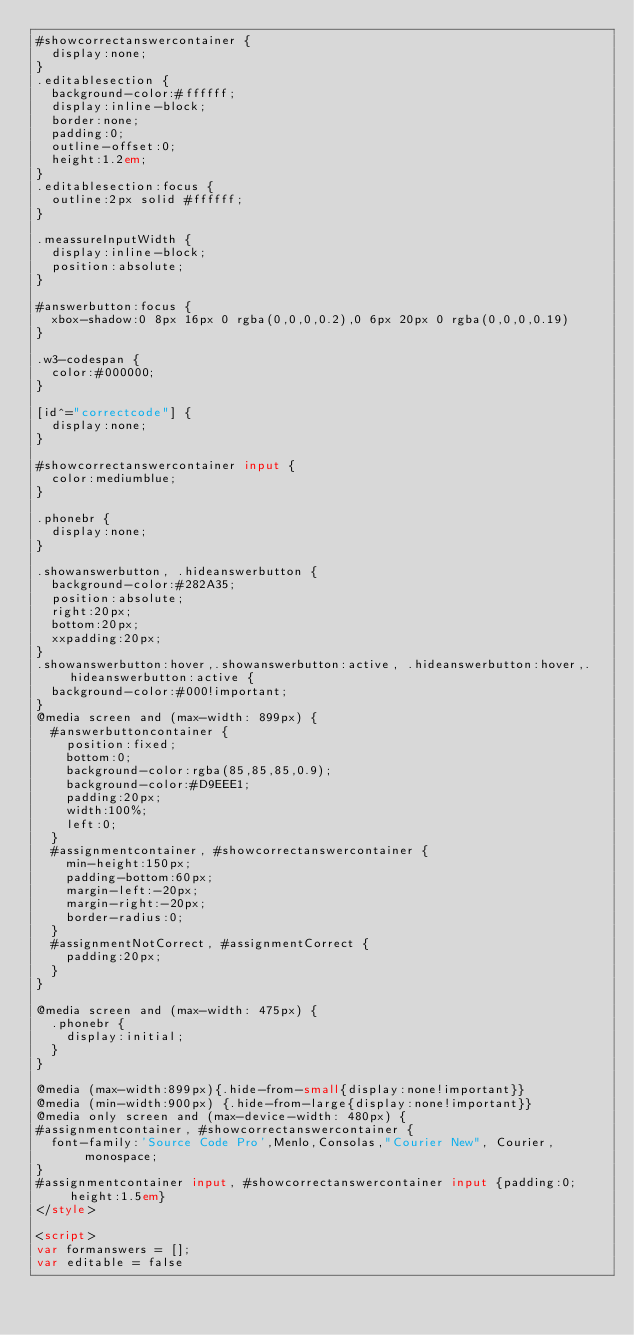<code> <loc_0><loc_0><loc_500><loc_500><_HTML_>#showcorrectanswercontainer {
  display:none;
}
.editablesection {
  background-color:#ffffff;
  display:inline-block;
  border:none;
  padding:0;
  outline-offset:0;
  height:1.2em;
}
.editablesection:focus {
  outline:2px solid #ffffff;
}

.meassureInputWidth {
  display:inline-block;
  position:absolute;
}

#answerbutton:focus {
  xbox-shadow:0 8px 16px 0 rgba(0,0,0,0.2),0 6px 20px 0 rgba(0,0,0,0.19)
}

.w3-codespan {
  color:#000000;
}

[id^="correctcode"] {
  display:none;
}

#showcorrectanswercontainer input {
  color:mediumblue;
}

.phonebr {
  display:none;
}

.showanswerbutton, .hideanswerbutton {
  background-color:#282A35;
  position:absolute;
  right:20px;
  bottom:20px;
  xxpadding:20px;
}
.showanswerbutton:hover,.showanswerbutton:active, .hideanswerbutton:hover,.hideanswerbutton:active {
  background-color:#000!important;
}
@media screen and (max-width: 899px) {
  #answerbuttoncontainer {
    position:fixed;
    bottom:0;
    background-color:rgba(85,85,85,0.9);
    background-color:#D9EEE1;
    padding:20px;
    width:100%;
    left:0;
  }
  #assignmentcontainer, #showcorrectanswercontainer {
    min-height:150px;
    padding-bottom:60px;
    margin-left:-20px;
    margin-right:-20px;
    border-radius:0;
  }
  #assignmentNotCorrect, #assignmentCorrect {
    padding:20px;
  }
}

@media screen and (max-width: 475px) {
  .phonebr {
    display:initial;
  }
}

@media (max-width:899px){.hide-from-small{display:none!important}}
@media (min-width:900px) {.hide-from-large{display:none!important}}
@media only screen and (max-device-width: 480px) {
#assignmentcontainer, #showcorrectanswercontainer {
  font-family:'Source Code Pro',Menlo,Consolas,"Courier New", Courier, monospace;
}
#assignmentcontainer input, #showcorrectanswercontainer input {padding:0;height:1.5em}
</style>

<script>
var formanswers = [];
var editable = false</code> 